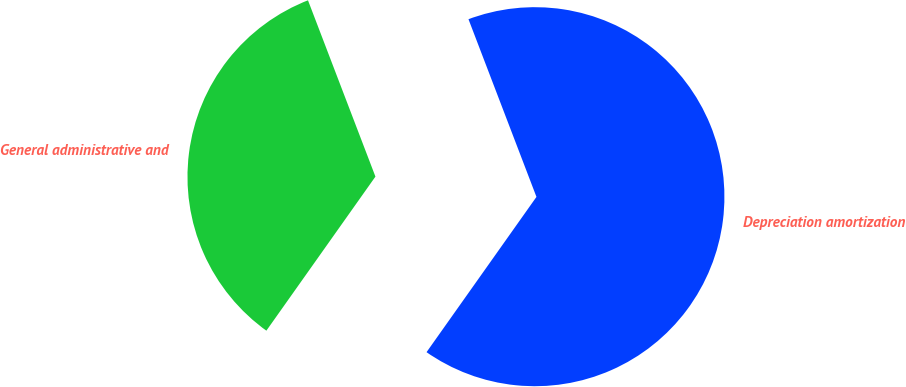Convert chart. <chart><loc_0><loc_0><loc_500><loc_500><pie_chart><fcel>Depreciation amortization and<fcel>General administrative and<nl><fcel>65.62%<fcel>34.38%<nl></chart> 